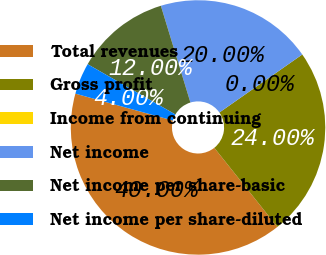<chart> <loc_0><loc_0><loc_500><loc_500><pie_chart><fcel>Total revenues<fcel>Gross profit<fcel>Income from continuing<fcel>Net income<fcel>Net income per share-basic<fcel>Net income per share-diluted<nl><fcel>40.0%<fcel>24.0%<fcel>0.0%<fcel>20.0%<fcel>12.0%<fcel>4.0%<nl></chart> 